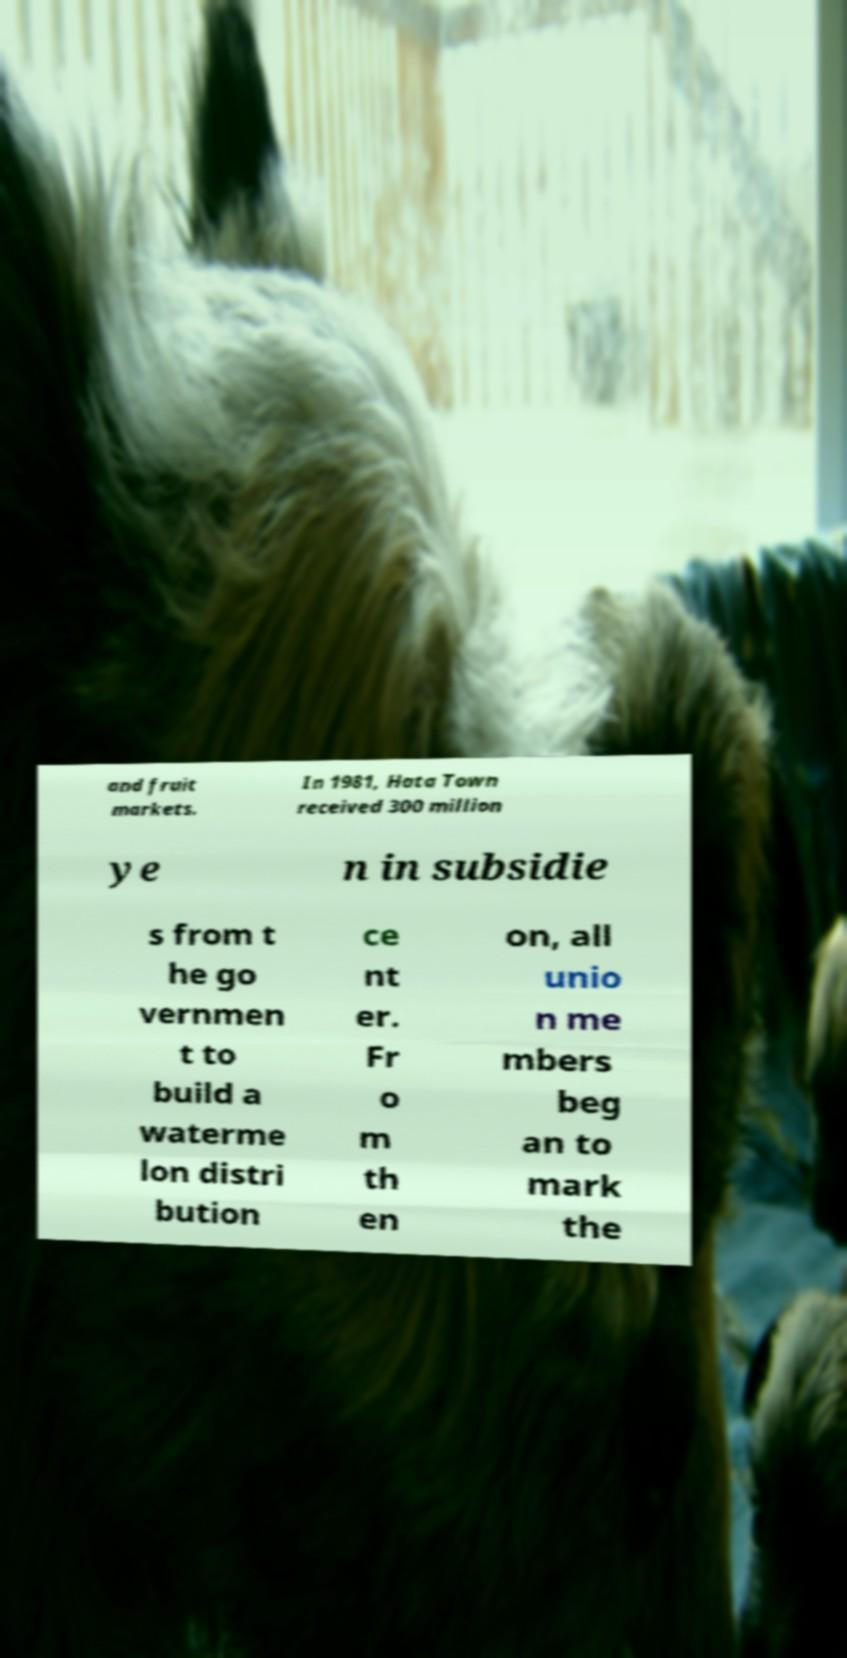For documentation purposes, I need the text within this image transcribed. Could you provide that? and fruit markets. In 1981, Hata Town received 300 million ye n in subsidie s from t he go vernmen t to build a waterme lon distri bution ce nt er. Fr o m th en on, all unio n me mbers beg an to mark the 